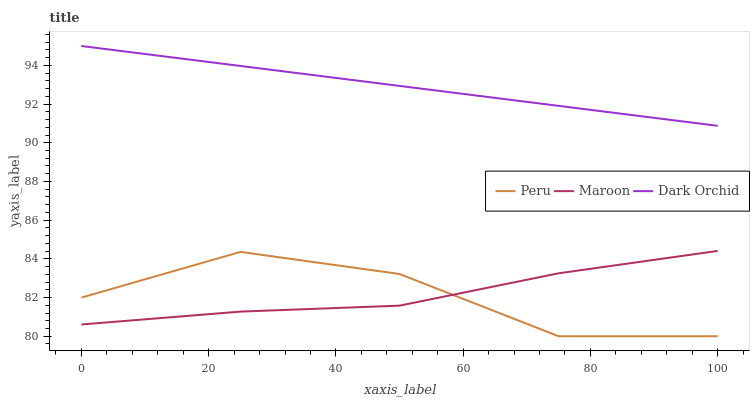Does Maroon have the minimum area under the curve?
Answer yes or no. No. Does Maroon have the maximum area under the curve?
Answer yes or no. No. Is Maroon the smoothest?
Answer yes or no. No. Is Maroon the roughest?
Answer yes or no. No. Does Maroon have the lowest value?
Answer yes or no. No. Does Maroon have the highest value?
Answer yes or no. No. Is Peru less than Dark Orchid?
Answer yes or no. Yes. Is Dark Orchid greater than Maroon?
Answer yes or no. Yes. Does Peru intersect Dark Orchid?
Answer yes or no. No. 